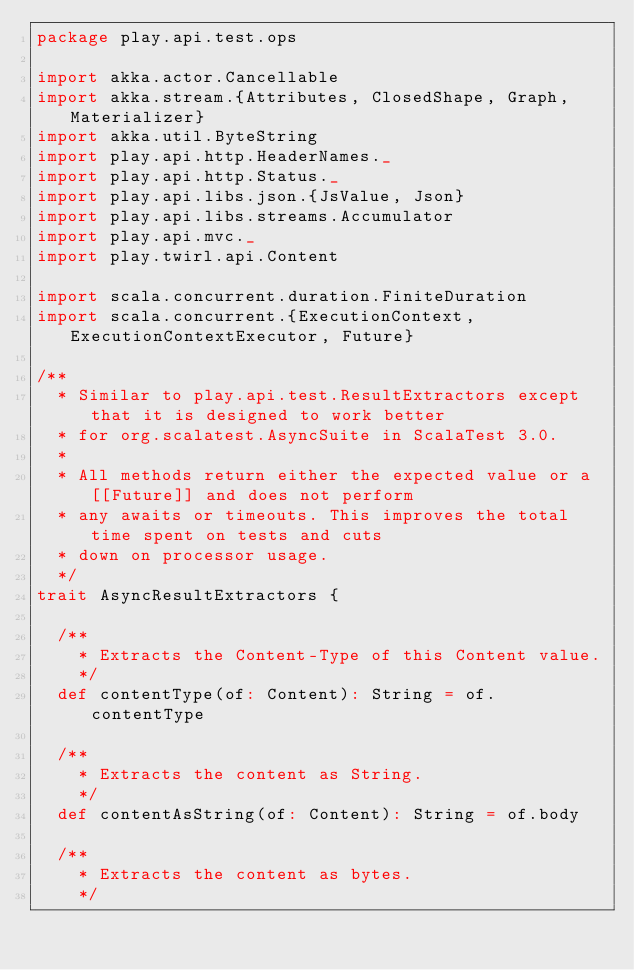<code> <loc_0><loc_0><loc_500><loc_500><_Scala_>package play.api.test.ops

import akka.actor.Cancellable
import akka.stream.{Attributes, ClosedShape, Graph, Materializer}
import akka.util.ByteString
import play.api.http.HeaderNames._
import play.api.http.Status._
import play.api.libs.json.{JsValue, Json}
import play.api.libs.streams.Accumulator
import play.api.mvc._
import play.twirl.api.Content

import scala.concurrent.duration.FiniteDuration
import scala.concurrent.{ExecutionContext, ExecutionContextExecutor, Future}

/**
  * Similar to play.api.test.ResultExtractors except that it is designed to work better
  * for org.scalatest.AsyncSuite in ScalaTest 3.0.
  *
  * All methods return either the expected value or a [[Future]] and does not perform
  * any awaits or timeouts. This improves the total time spent on tests and cuts
  * down on processor usage.
  */
trait AsyncResultExtractors {

  /**
    * Extracts the Content-Type of this Content value.
    */
  def contentType(of: Content): String = of.contentType

  /**
    * Extracts the content as String.
    */
  def contentAsString(of: Content): String = of.body

  /**
    * Extracts the content as bytes.
    */</code> 